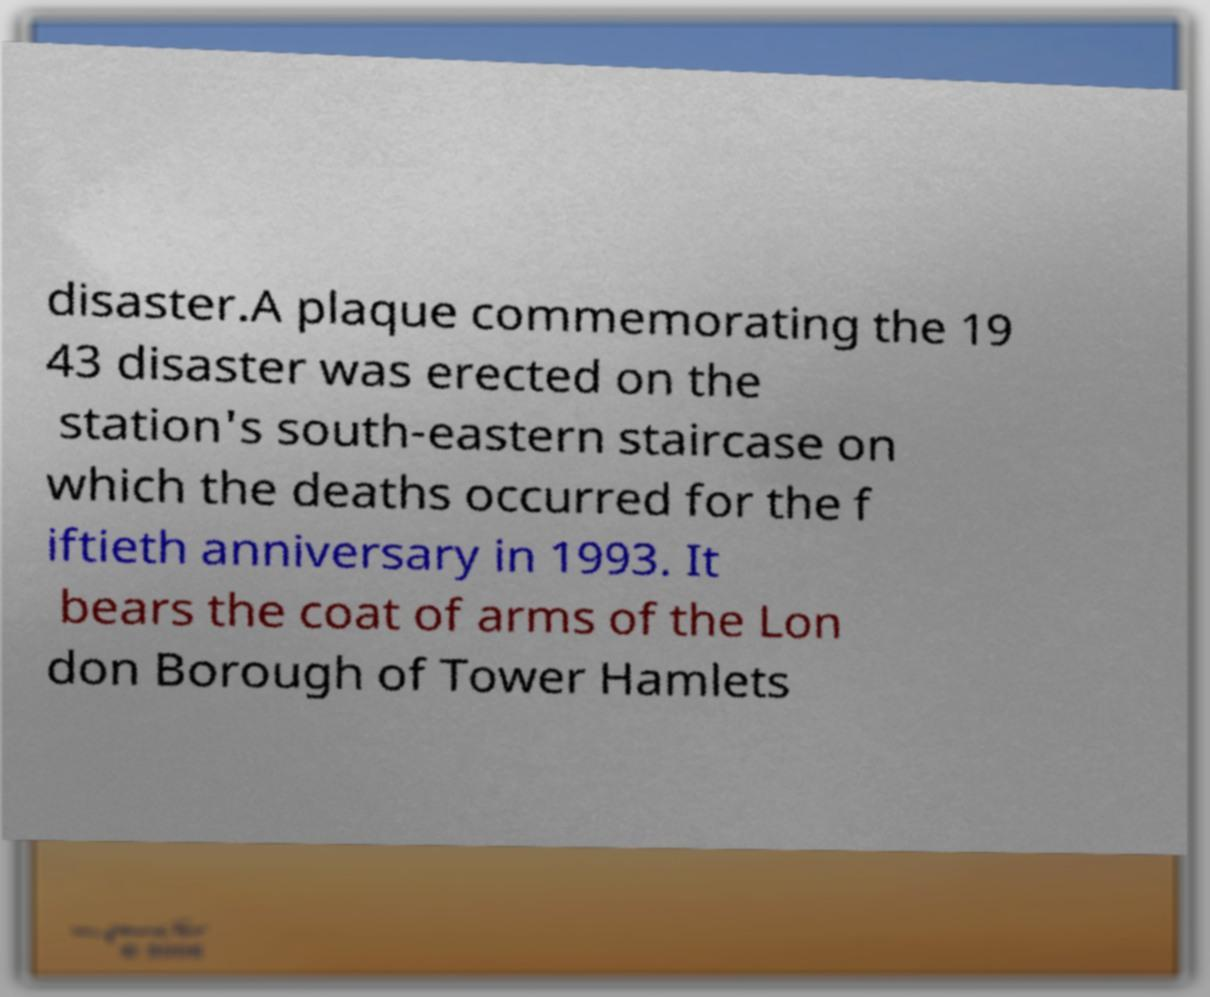Please identify and transcribe the text found in this image. disaster.A plaque commemorating the 19 43 disaster was erected on the station's south-eastern staircase on which the deaths occurred for the f iftieth anniversary in 1993. It bears the coat of arms of the Lon don Borough of Tower Hamlets 